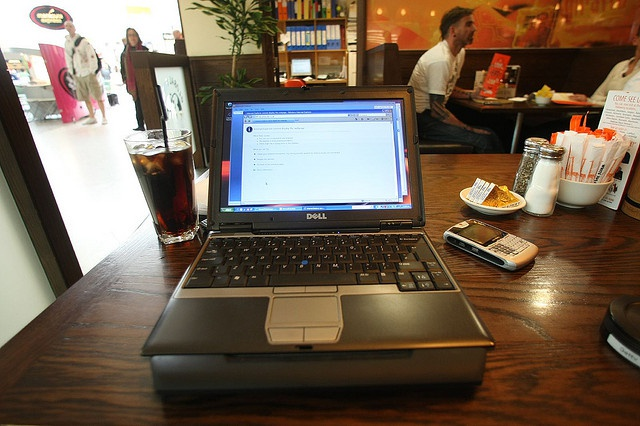Describe the objects in this image and their specific colors. I can see dining table in white, black, maroon, and gray tones, laptop in white, black, lightblue, maroon, and gray tones, cup in white, black, maroon, and gray tones, people in white, black, maroon, and tan tones, and potted plant in white, black, darkgreen, and olive tones in this image. 